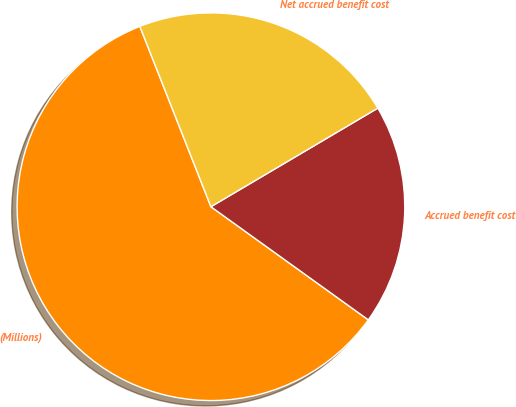<chart> <loc_0><loc_0><loc_500><loc_500><pie_chart><fcel>(Millions)<fcel>Accrued benefit cost<fcel>Net accrued benefit cost<nl><fcel>59.1%<fcel>18.41%<fcel>22.48%<nl></chart> 